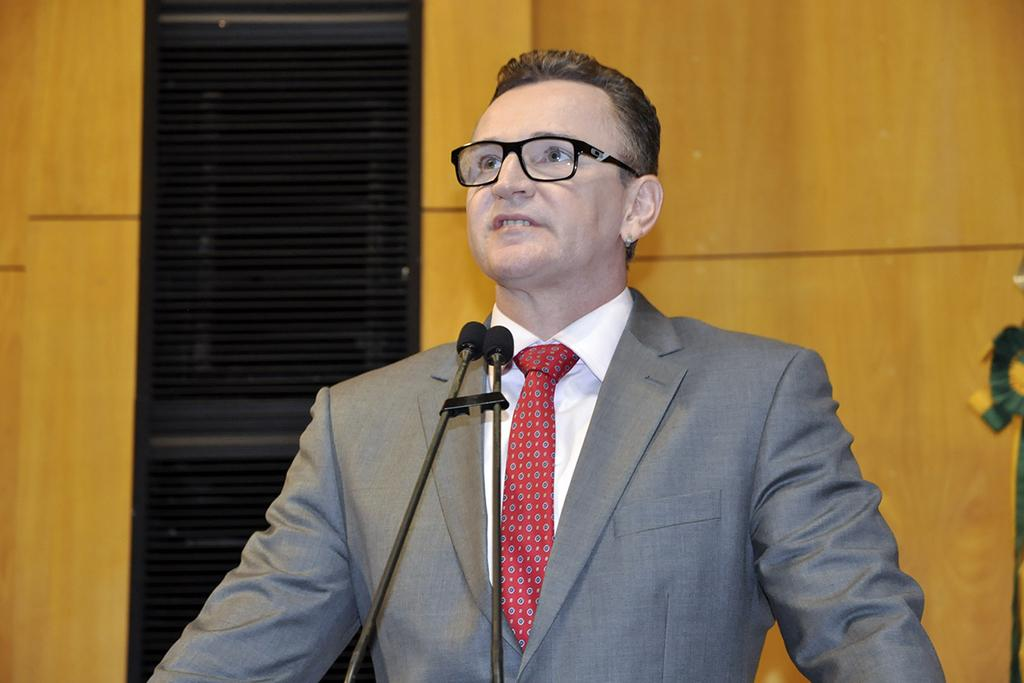What is the main subject of the image? There is a person standing in the center of the image. What is in front of the person? There are two microphones in front of the person. What can be seen in the background of the image? There is a wooden door and other objects visible in the background of the image. How many fingers can be seen on the person's hand in the image? The image does not show the person's hand or fingers, so it cannot be determined from the image. 